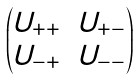Convert formula to latex. <formula><loc_0><loc_0><loc_500><loc_500>\begin{pmatrix} U _ { + + } & U _ { + - } \\ U _ { - + } & U _ { - - } \end{pmatrix}</formula> 